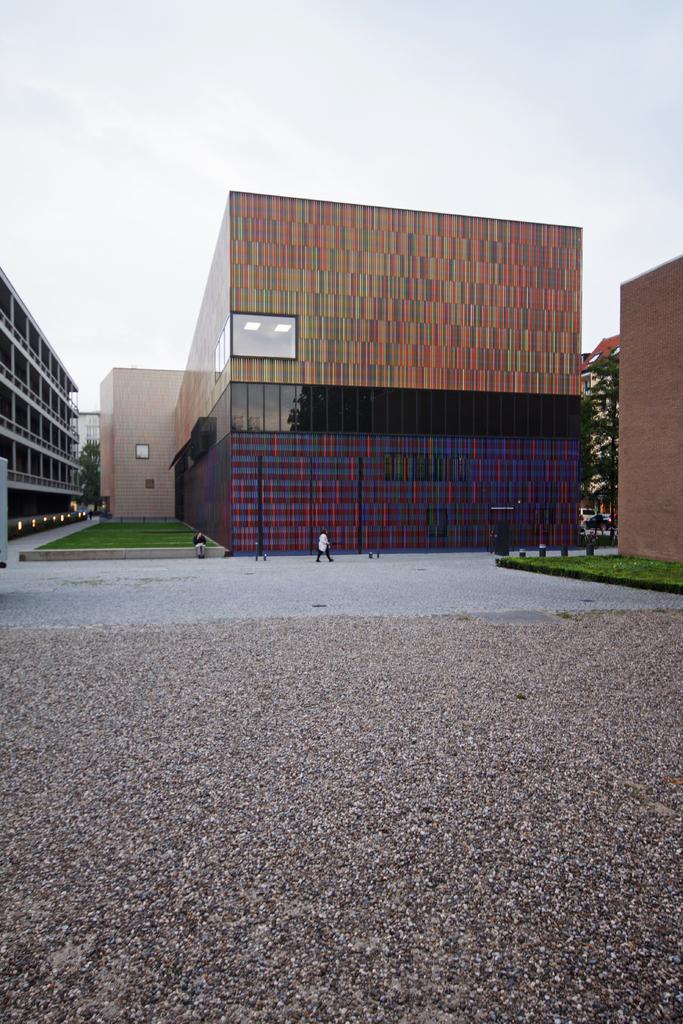Can you describe this image briefly? In this image there is a building in the middle. Beside the building there is a person walking on the floor. At the top there is sky. On the left side there is a building. At the bottom there is floor. On the right side there is tree between both the buildings. Beside the building there is a garden. 